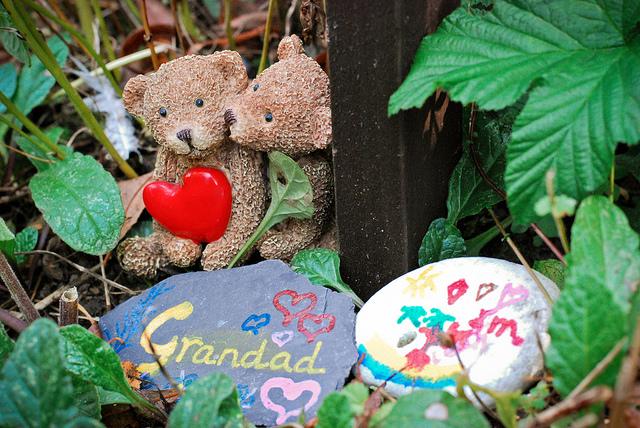What is the teddy bear holding that is red?
Quick response, please. Heart. What colors are the hearts on the gray rock?
Quick response, please. Pink, blue, red. What does the gray rock say?
Be succinct. Grandad. 